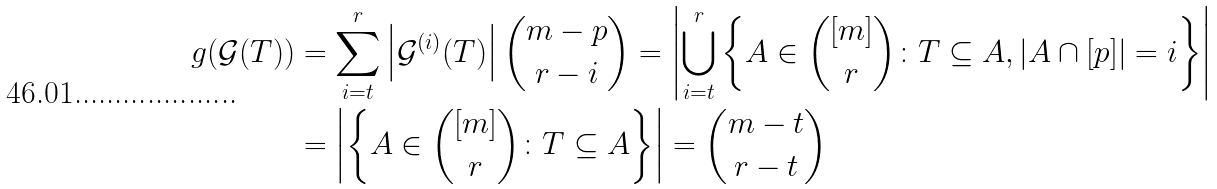Convert formula to latex. <formula><loc_0><loc_0><loc_500><loc_500>g ( \mathcal { G } ( T ) ) & = \sum _ { i = t } ^ { r } \left | \mathcal { G } ^ { ( i ) } ( T ) \right | { m - p \choose r - i } = \left | \bigcup _ { i = t } ^ { r } \left \{ A \in { [ m ] \choose r } \colon T \subseteq A , | A \cap [ p ] | = i \right \} \right | \\ & = \left | \left \{ A \in { [ m ] \choose r } \colon T \subseteq A \right \} \right | = { m - t \choose r - t }</formula> 